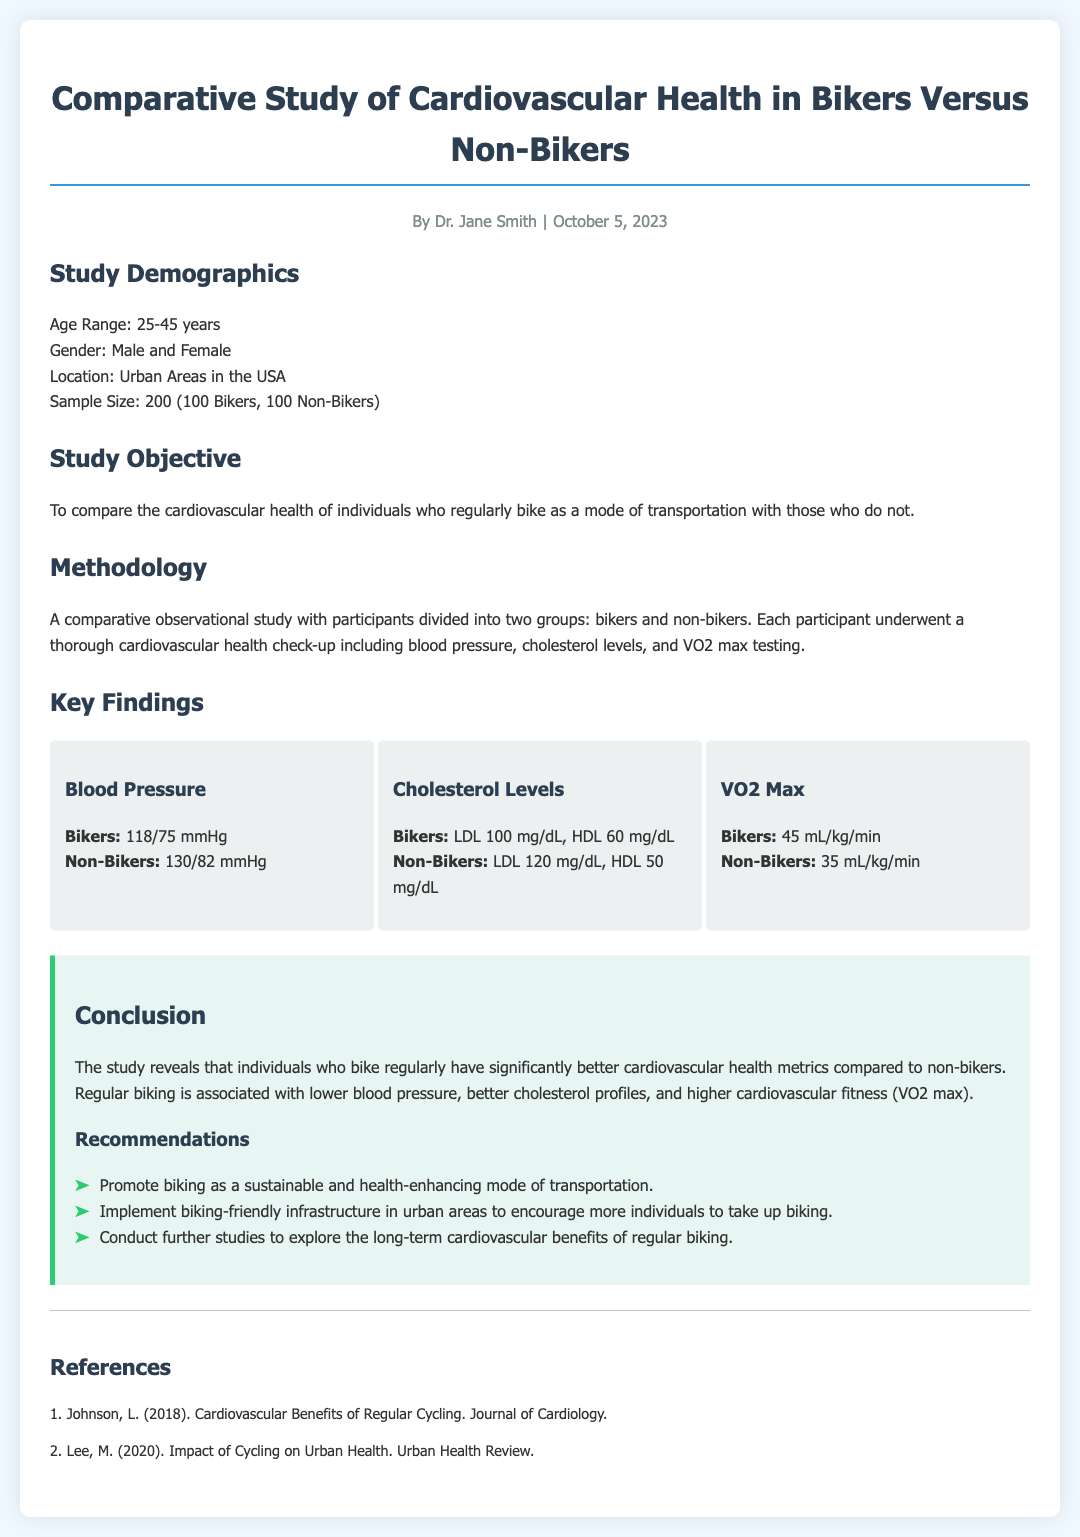What is the age range of participants? The study demographics specify that the age range for participants is between 25-45 years.
Answer: 25-45 years How many participants were bikers? The sample size indicated in the document shows that there were 100 bikers in the study.
Answer: 100 What was the LDL cholesterol level for non-bikers? The key findings section reveals that the LDL cholesterol level for non-bikers was 120 mg/dL.
Answer: 120 mg/dL What is the VO2 max for bikers? The findings section provides that the VO2 max for bikers is 45 mL/kg/min.
Answer: 45 mL/kg/min What is the conclusion about cardiovascular health between bikers and non-bikers? The conclusion states that bikers have significantly better cardiovascular health metrics compared to non-bikers.
Answer: Better cardiovascular health metrics What is one recommendation from the study? The recommendations section lists several points, one of which is to promote biking as a sustainable and health-enhancing mode of transportation.
Answer: Promote biking as a sustainable and health-enhancing mode of transportation What type of study was conducted? The document explains that a comparative observational study was conducted to assess cardiovascular health.
Answer: Comparative observational study How many non-bikers were in the study? The sample size shows that there were also 100 non-bikers participating in the study.
Answer: 100 